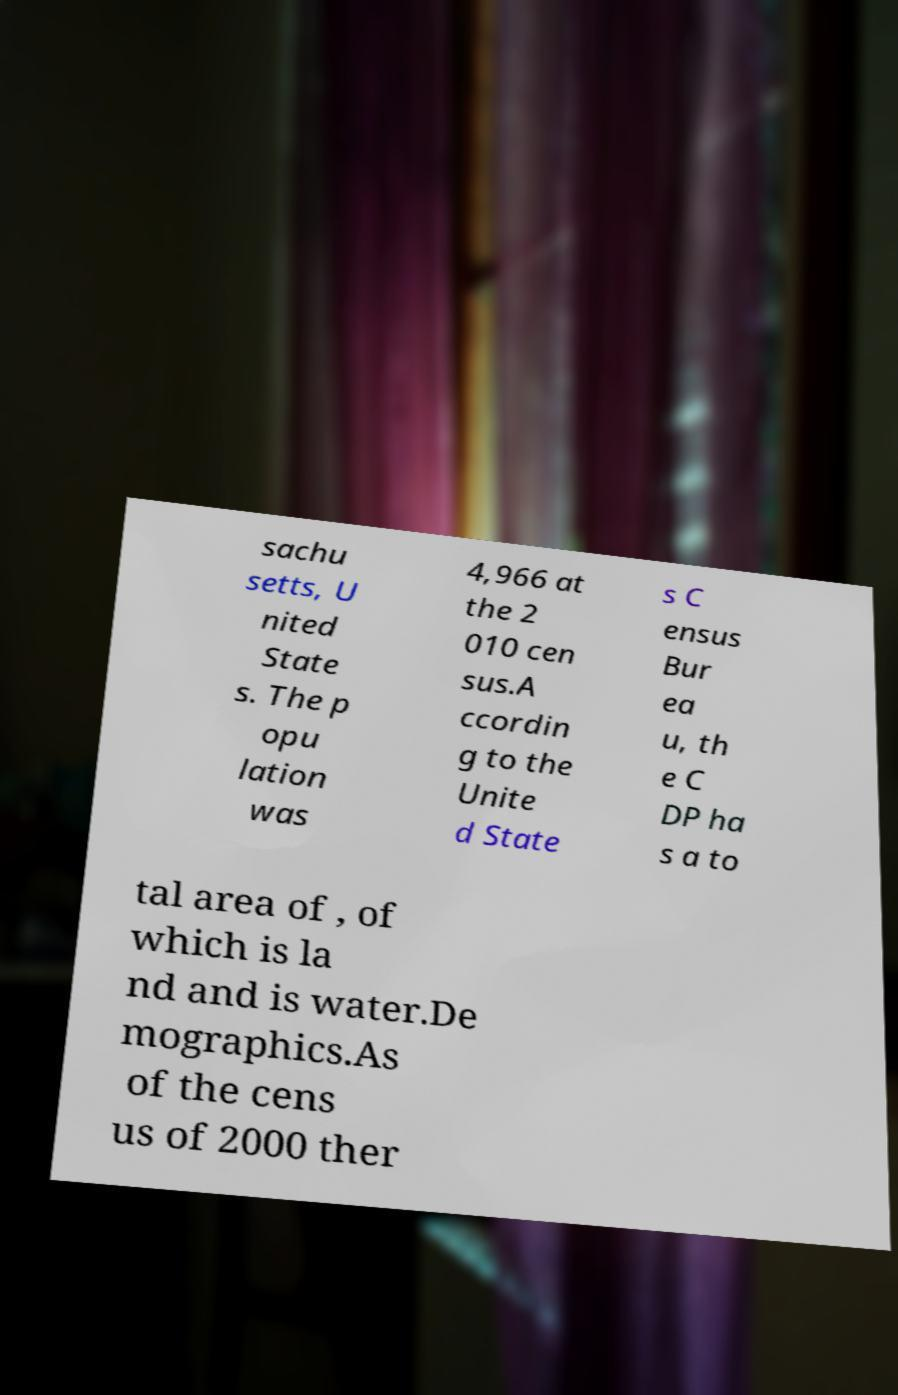Could you assist in decoding the text presented in this image and type it out clearly? sachu setts, U nited State s. The p opu lation was 4,966 at the 2 010 cen sus.A ccordin g to the Unite d State s C ensus Bur ea u, th e C DP ha s a to tal area of , of which is la nd and is water.De mographics.As of the cens us of 2000 ther 